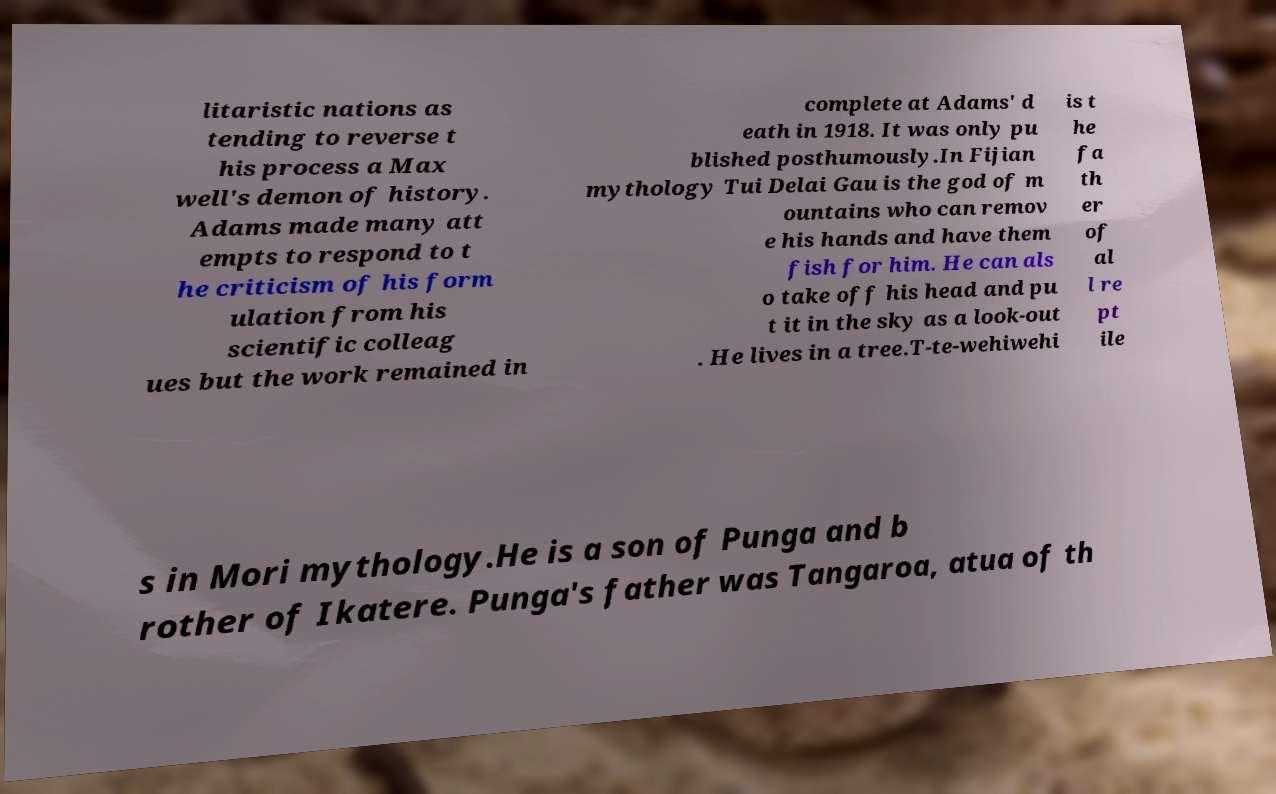Could you extract and type out the text from this image? litaristic nations as tending to reverse t his process a Max well's demon of history. Adams made many att empts to respond to t he criticism of his form ulation from his scientific colleag ues but the work remained in complete at Adams' d eath in 1918. It was only pu blished posthumously.In Fijian mythology Tui Delai Gau is the god of m ountains who can remov e his hands and have them fish for him. He can als o take off his head and pu t it in the sky as a look-out . He lives in a tree.T-te-wehiwehi is t he fa th er of al l re pt ile s in Mori mythology.He is a son of Punga and b rother of Ikatere. Punga's father was Tangaroa, atua of th 